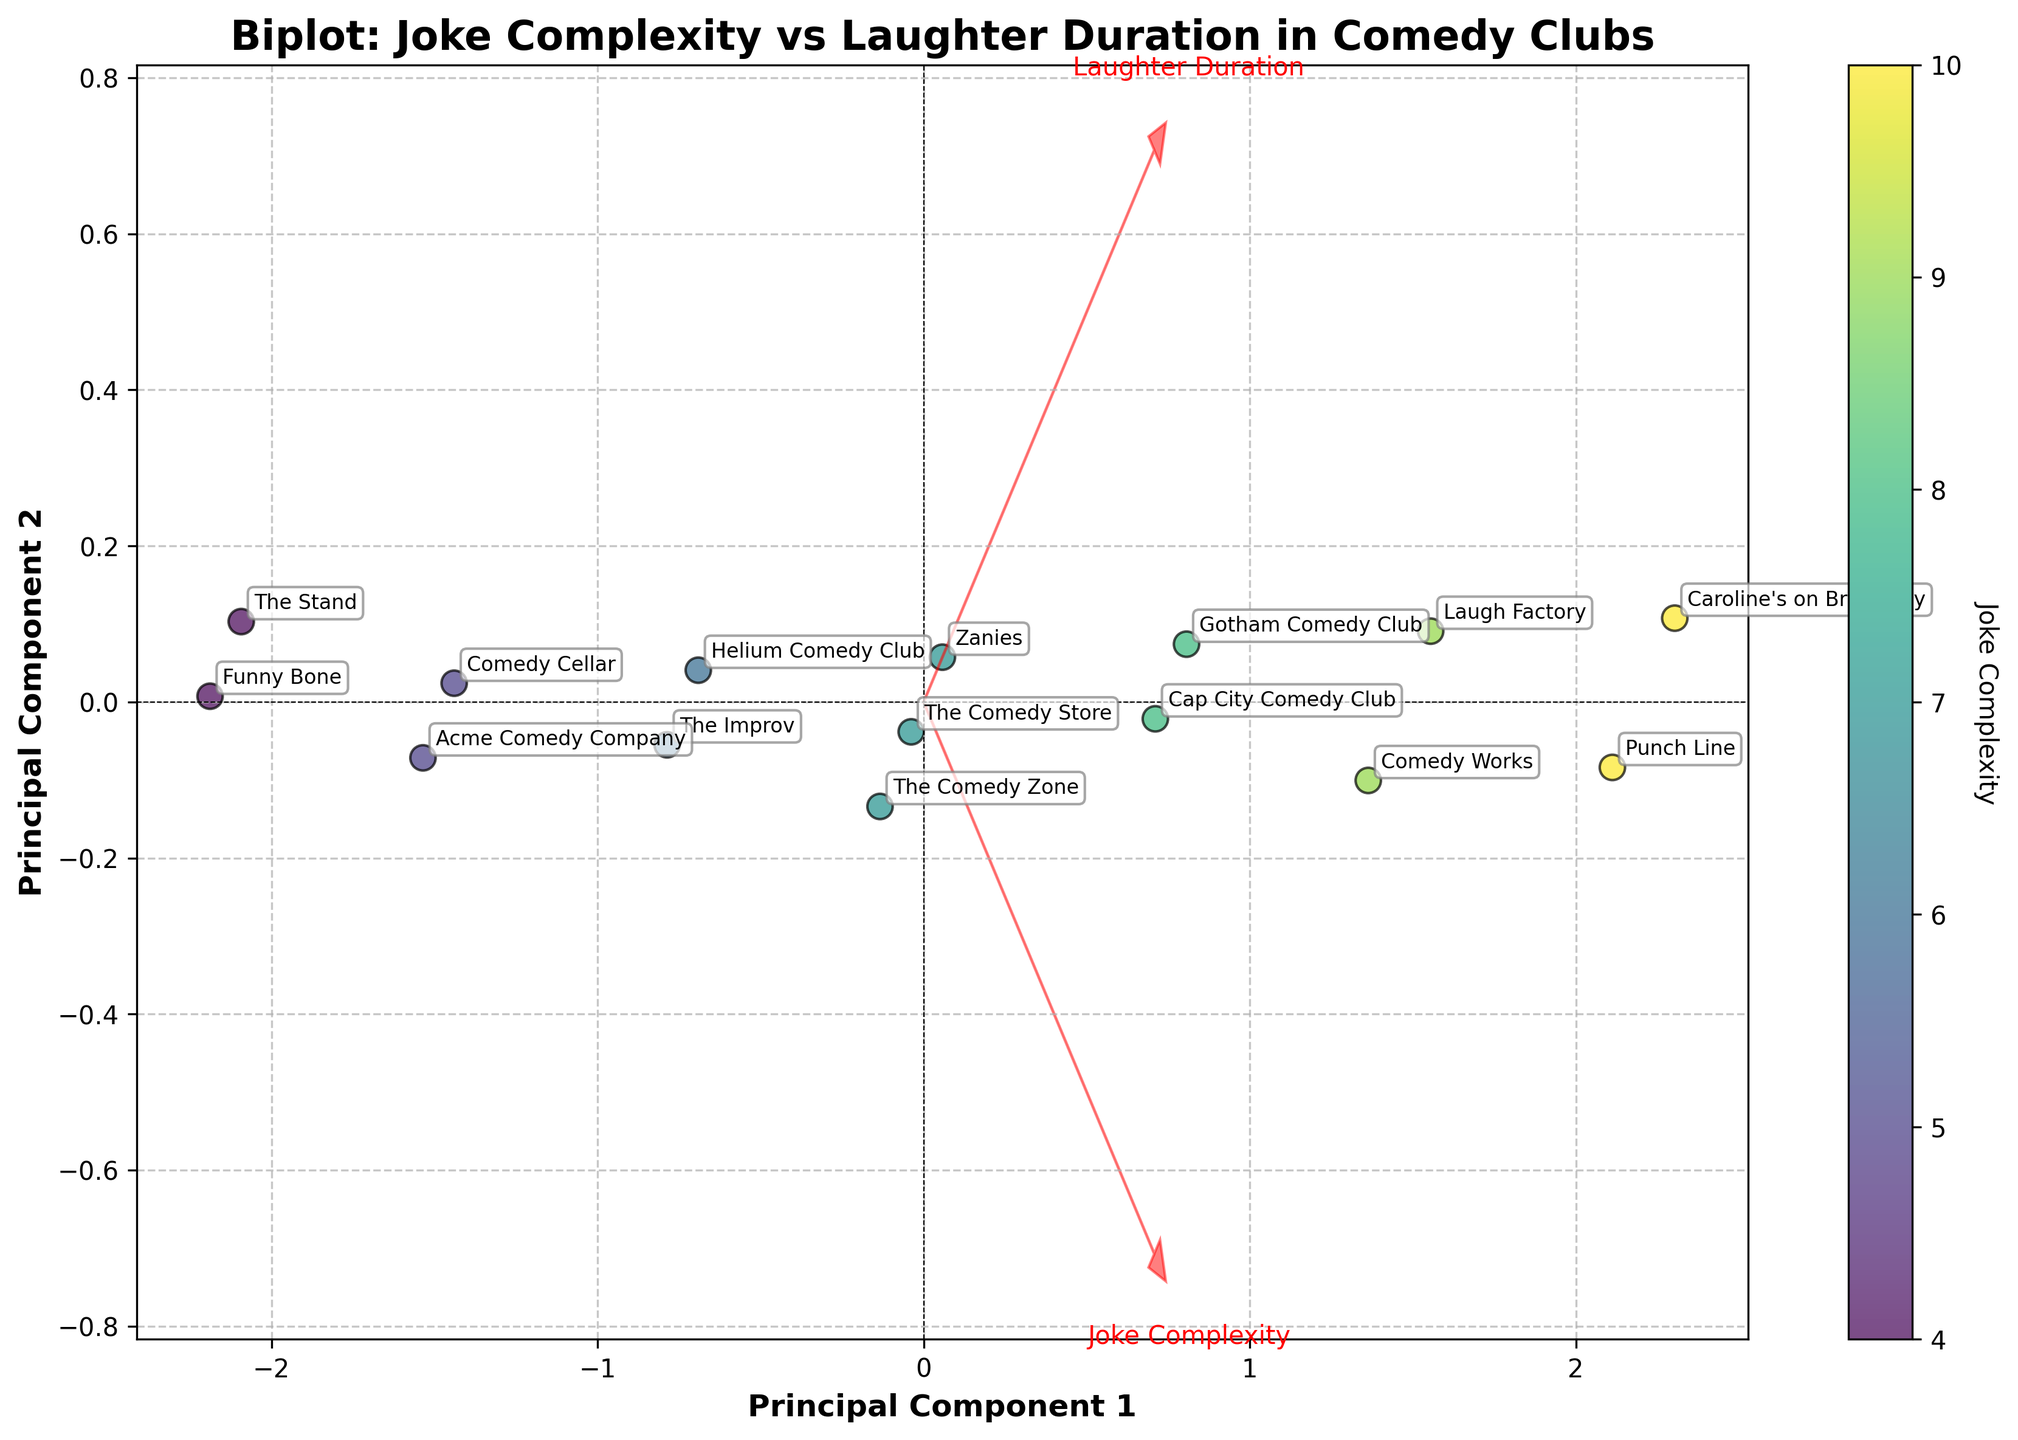What is the title of the biplot? The title of the plot is typically located at the top of the figure. In this case, it reads "Biplot: Joke Complexity vs Laughter Duration in Comedy Clubs".
Answer: Biplot: Joke Complexity vs Laughter Duration in Comedy Clubs How many comedy clubs are represented in the plot? Each data point on the plot represents a comedy club, and there are small annotations with club names near each point. Counting these, there are 15 comedy clubs.
Answer: 15 Which feature vectors are represented by the red arrows? The red arrows in a biplot represent the original axes of the feature vectors. In this plot, they are labeled "Joke Complexity" and "Laughter Duration".
Answer: Joke Complexity and Laughter Duration Which comedy club has the highest joke complexity? The color of the data points represents joke complexity, and the color bar can be referenced to identify the club with maximum complexity. Darker colors (closer to yellow) suggest higher complexity, and the club associated with the darkest color is "Caroline’s on Broadway".
Answer: Caroline’s on Broadway What are the axes labeled as in the biplot? The axes in the biplot are usually labeled to indicate the principal components derived from PCA. Here, the x-axis is labeled "Principal Component 1" and the y-axis "Principal Component 2".
Answer: Principal Component 1 and Principal Component 2 Which comedy club has the lowest laughter duration? The position of the data point along the y-axis (Principal Component 2) represents laughter duration. The club nearest to the bottom (lowest y-value) is "Funny Bone".
Answer: Funny Bone Which comedy club is most positively correlated with joke complexity? In a biplot, data points that are in the direction of the joke complexity arrow (but distant from the origin) and have a high value in the color bar indicate positive correlation. "Caroline’s on Broadway" appears in this direction and is the most correlated.
Answer: Caroline’s on Broadway Describe the relationship between joke complexity and laughter duration. From the plot, the direction and length of the arrows suggest a positive correlation between joke complexity and laughter duration. As joke complexity increases, laughter duration also tends to increase.
Answer: Positive correlation Which feature vector has a greater impact on Principal Component 1? By observing the direction and length of the red arrows in relation to Principal Component 1, the arrow with a greater projection along this axis indicates a higher impact. "Joke Complexity" has a larger projection on Principal Component 1.
Answer: Joke Complexity Is "Comedy Cellar" above or below the average joke complexity line? By examining the scatter plot and the relative position of "Comedy Cellar" in terms of color and placement, we see it has a lighter color corresponding to a lower joke complexity than some other clubs closer to the average.
Answer: Below 